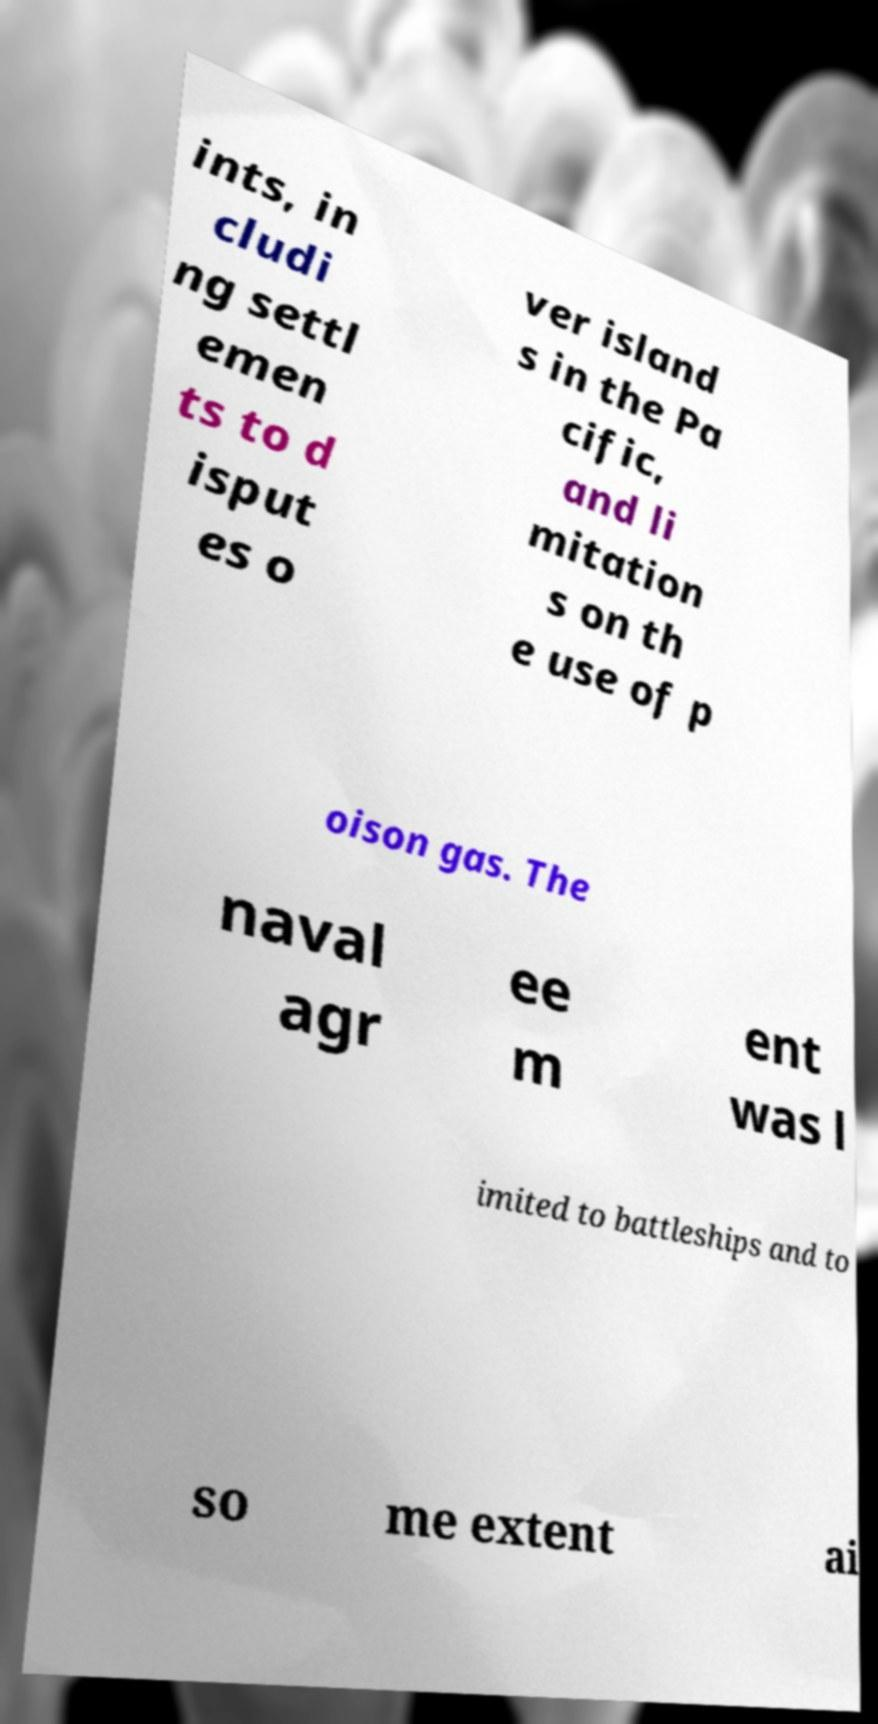Please read and relay the text visible in this image. What does it say? ints, in cludi ng settl emen ts to d isput es o ver island s in the Pa cific, and li mitation s on th e use of p oison gas. The naval agr ee m ent was l imited to battleships and to so me extent ai 